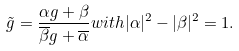Convert formula to latex. <formula><loc_0><loc_0><loc_500><loc_500>\tilde { g } = \frac { \alpha g + \beta } { \overline { \beta } g + \overline { \alpha } } w i t h | \alpha | ^ { 2 } - | \beta | ^ { 2 } = 1 .</formula> 